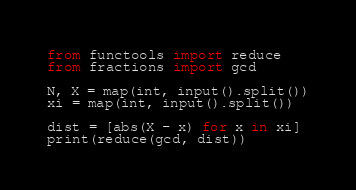Convert code to text. <code><loc_0><loc_0><loc_500><loc_500><_Python_>from functools import reduce
from fractions import gcd

N, X = map(int, input().split())
xi = map(int, input().split())

dist = [abs(X - x) for x in xi]
print(reduce(gcd, dist))
</code> 